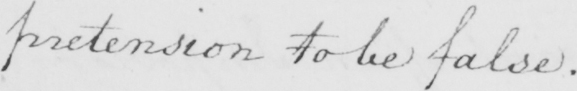What is written in this line of handwriting? pretension to be false . 